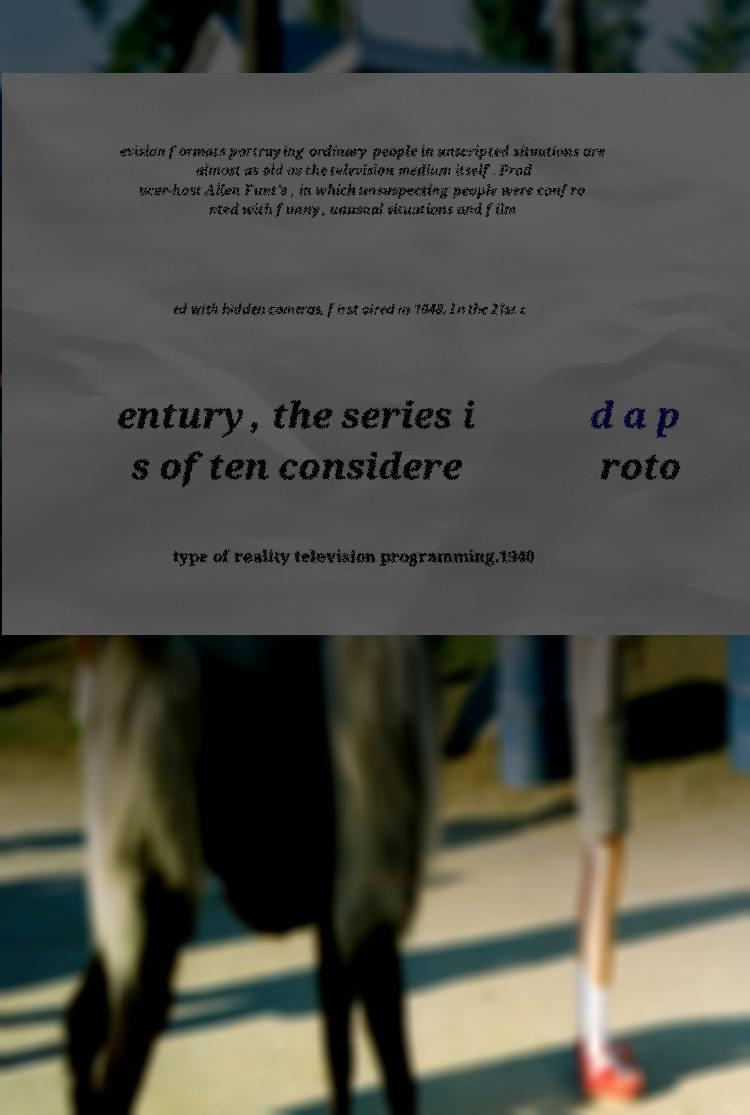Please identify and transcribe the text found in this image. evision formats portraying ordinary people in unscripted situations are almost as old as the television medium itself. Prod ucer-host Allen Funt's , in which unsuspecting people were confro nted with funny, unusual situations and film ed with hidden cameras, first aired in 1948. In the 21st c entury, the series i s often considere d a p roto type of reality television programming.1940 